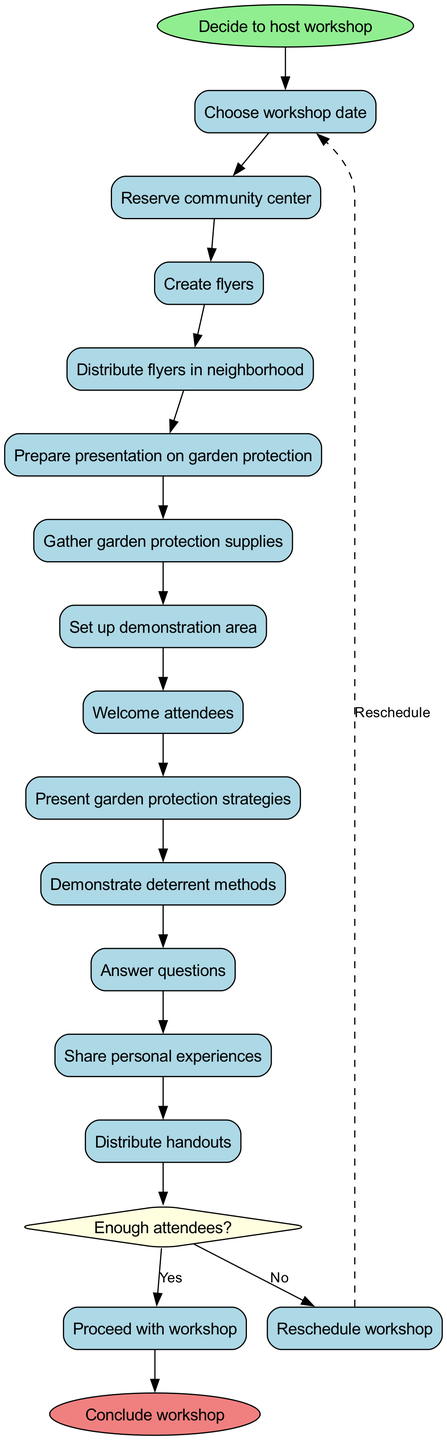What is the first activity listed in the diagram? The diagram outlines activities in sequence, starting from the first one when the activity nodes are created. The first activity is therefore the first one on the list, which is "Choose workshop date."
Answer: Choose workshop date How many activities are there in total? By counting the number of activities listed in the diagram, we find that the total is 12 activities. Each activity is a distinct step listed in the activities section of the diagram.
Answer: 12 What decision is made after the last activity? The last activity ("Distribute handouts") leads to a condition-checking node, which involves a decision regarding the number of attendees. So the decision made after this activity is whether there are enough attendees.
Answer: Enough attendees? What happens if there are not enough attendees? The outcome of the decision node indicates that if there are not enough attendees (i.e., the answer is "No"), the flow goes back to the first activity ("Choose workshop date") as shown by the dashed edge labeled "Reschedule."
Answer: Reschedule workshop What is the final activity that concludes the workshop? The flow from the decision "Yes" leads to the end of the workshop, which is marked as "Conclude workshop," representing the final step in the activity flow.
Answer: Conclude workshop How many edges are there leading from the activities to the decision node? Each of the activities connects to the decision node, providing a direct path from the last activity to the decision point. There is just one edge leading from the last activity to the decision node because only the last activity connects to it.
Answer: 1 What color is used for the decision node in the diagram? The diagram specifies attributes for the decision node, including its shape and color. The decision node is filled with light yellow, as indicated by the attributes set within the diagram creation.
Answer: Light yellow What does the decision node check? The decision node evaluates whether there are enough attendees for the workshop by checking the condition "Enough attendees?" which determines the next flow based on the attendees' count.
Answer: Enough attendees? 